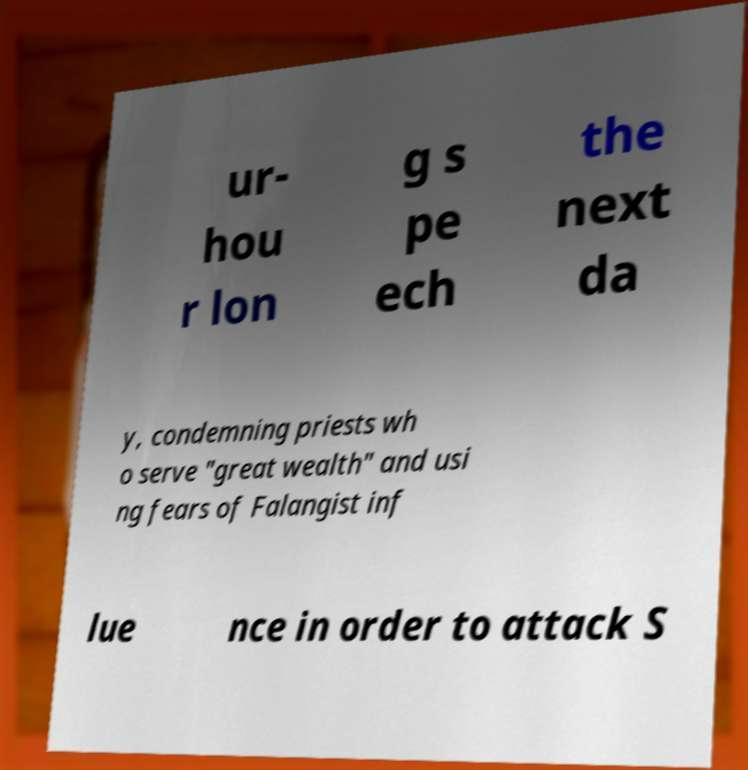What messages or text are displayed in this image? I need them in a readable, typed format. ur- hou r lon g s pe ech the next da y, condemning priests wh o serve "great wealth" and usi ng fears of Falangist inf lue nce in order to attack S 